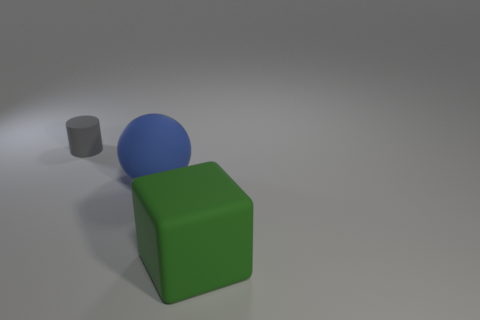There is a rubber block; is it the same size as the thing on the left side of the large matte sphere?
Your response must be concise. No. There is a big matte object behind the green block; what number of small matte cylinders are on the right side of it?
Ensure brevity in your answer.  0. What number of objects are either tiny rubber cylinders or rubber cubes?
Offer a terse response. 2. Does the gray object have the same shape as the large green matte thing?
Your response must be concise. No. What is the material of the large cube?
Offer a terse response. Rubber. What number of rubber things are both in front of the small cylinder and to the left of the large block?
Your response must be concise. 1. Do the blue thing and the matte cylinder have the same size?
Give a very brief answer. No. There is a matte thing in front of the blue rubber thing; is its size the same as the blue object?
Keep it short and to the point. Yes. The matte object on the right side of the big blue thing is what color?
Give a very brief answer. Green. What number of large yellow cylinders are there?
Keep it short and to the point. 0. 